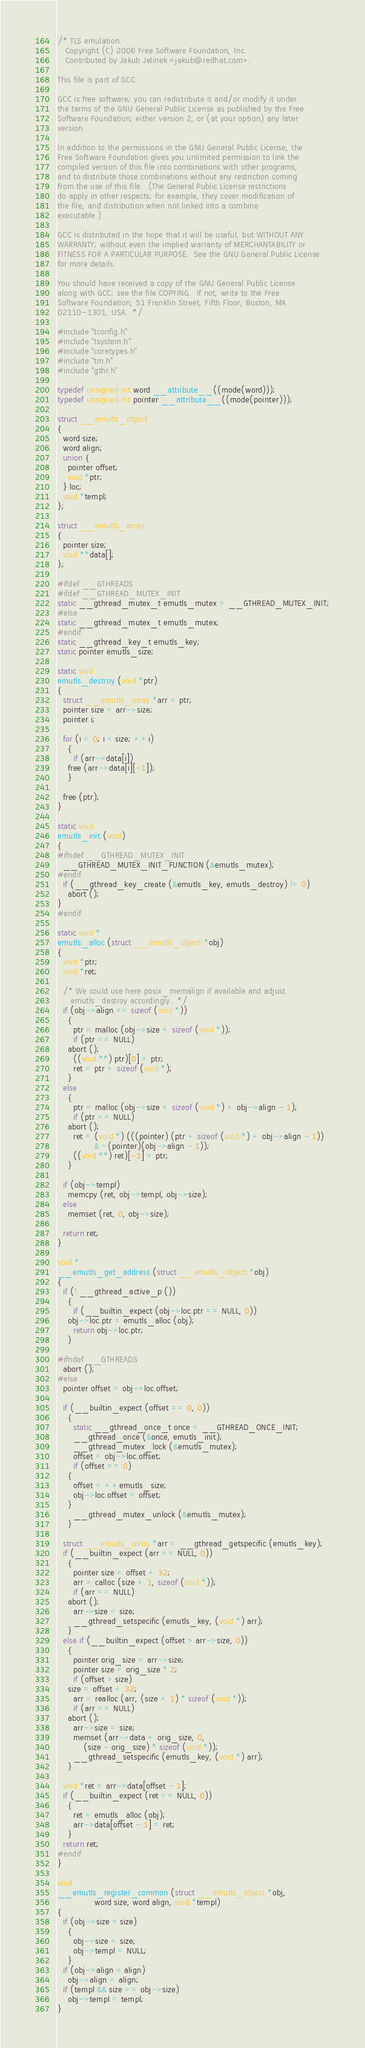Convert code to text. <code><loc_0><loc_0><loc_500><loc_500><_C_>/* TLS emulation.
   Copyright (C) 2006 Free Software Foundation, Inc.
   Contributed by Jakub Jelinek <jakub@redhat.com>.

This file is part of GCC.

GCC is free software; you can redistribute it and/or modify it under
the terms of the GNU General Public License as published by the Free
Software Foundation; either version 2, or (at your option) any later
version.

In addition to the permissions in the GNU General Public License, the
Free Software Foundation gives you unlimited permission to link the
compiled version of this file into combinations with other programs,
and to distribute those combinations without any restriction coming
from the use of this file.  (The General Public License restrictions
do apply in other respects; for example, they cover modification of
the file, and distribution when not linked into a combine
executable.)

GCC is distributed in the hope that it will be useful, but WITHOUT ANY
WARRANTY; without even the implied warranty of MERCHANTABILITY or
FITNESS FOR A PARTICULAR PURPOSE.  See the GNU General Public License
for more details.

You should have received a copy of the GNU General Public License
along with GCC; see the file COPYING.  If not, write to the Free
Software Foundation, 51 Franklin Street, Fifth Floor, Boston, MA
02110-1301, USA.  */

#include "tconfig.h"
#include "tsystem.h"
#include "coretypes.h"
#include "tm.h"
#include "gthr.h"

typedef unsigned int word __attribute__((mode(word)));
typedef unsigned int pointer __attribute__((mode(pointer)));

struct __emutls_object
{
  word size;
  word align;
  union {
    pointer offset;
    void *ptr;
  } loc;
  void *templ;
};

struct __emutls_array
{
  pointer size;
  void **data[];
};

#ifdef __GTHREADS
#ifdef __GTHREAD_MUTEX_INIT
static __gthread_mutex_t emutls_mutex = __GTHREAD_MUTEX_INIT;
#else
static __gthread_mutex_t emutls_mutex;
#endif
static __gthread_key_t emutls_key;
static pointer emutls_size;

static void
emutls_destroy (void *ptr)
{
  struct __emutls_array *arr = ptr;
  pointer size = arr->size;
  pointer i;

  for (i = 0; i < size; ++i)
    {
      if (arr->data[i])
	free (arr->data[i][-1]);
    }

  free (ptr);
}

static void
emutls_init (void)
{
#ifndef __GTHREAD_MUTEX_INIT
  __GTHREAD_MUTEX_INIT_FUNCTION (&emutls_mutex);
#endif
  if (__gthread_key_create (&emutls_key, emutls_destroy) != 0)
    abort ();
}
#endif

static void *
emutls_alloc (struct __emutls_object *obj)
{
  void *ptr;
  void *ret;

  /* We could use here posix_memalign if available and adjust
     emutls_destroy accordingly.  */
  if (obj->align <= sizeof (void *))
    {
      ptr = malloc (obj->size + sizeof (void *));
      if (ptr == NULL)
	abort ();
      ((void **) ptr)[0] = ptr;
      ret = ptr + sizeof (void *);
    }
  else
    {
      ptr = malloc (obj->size + sizeof (void *) + obj->align - 1);
      if (ptr == NULL)
	abort ();
      ret = (void *) (((pointer) (ptr + sizeof (void *) + obj->align - 1))
		      & ~(pointer)(obj->align - 1));
      ((void **) ret)[-1] = ptr;
    }

  if (obj->templ)
    memcpy (ret, obj->templ, obj->size);
  else
    memset (ret, 0, obj->size);

  return ret;
}

void *
__emutls_get_address (struct __emutls_object *obj)
{
  if (! __gthread_active_p ())
    {
      if (__builtin_expect (obj->loc.ptr == NULL, 0))
	obj->loc.ptr = emutls_alloc (obj);
      return obj->loc.ptr;
    }

#ifndef __GTHREADS
  abort ();
#else
  pointer offset = obj->loc.offset;

  if (__builtin_expect (offset == 0, 0))
    {
      static __gthread_once_t once = __GTHREAD_ONCE_INIT;
      __gthread_once (&once, emutls_init);
      __gthread_mutex_lock (&emutls_mutex);
      offset = obj->loc.offset;
      if (offset == 0)
	{
	  offset = ++emutls_size;
	  obj->loc.offset = offset;
	}
      __gthread_mutex_unlock (&emutls_mutex);
    }

  struct __emutls_array *arr = __gthread_getspecific (emutls_key);
  if (__builtin_expect (arr == NULL, 0))
    {
      pointer size = offset + 32;
      arr = calloc (size + 1, sizeof (void *));
      if (arr == NULL)
	abort ();
      arr->size = size;
      __gthread_setspecific (emutls_key, (void *) arr);
    }
  else if (__builtin_expect (offset > arr->size, 0))
    {
      pointer orig_size = arr->size;
      pointer size = orig_size * 2;
      if (offset > size)
	size = offset + 32;
      arr = realloc (arr, (size + 1) * sizeof (void *));
      if (arr == NULL)
	abort ();
      arr->size = size;
      memset (arr->data + orig_size, 0,
	      (size - orig_size) * sizeof (void *));
      __gthread_setspecific (emutls_key, (void *) arr);
    }

  void *ret = arr->data[offset - 1];
  if (__builtin_expect (ret == NULL, 0))
    {
      ret = emutls_alloc (obj);
      arr->data[offset - 1] = ret;
    }
  return ret;
#endif
}

void
__emutls_register_common (struct __emutls_object *obj,
			  word size, word align, void *templ)
{
  if (obj->size < size)
    {
      obj->size = size;
      obj->templ = NULL;
    }
  if (obj->align < align)
    obj->align = align;
  if (templ && size == obj->size)
    obj->templ = templ;
}
</code> 